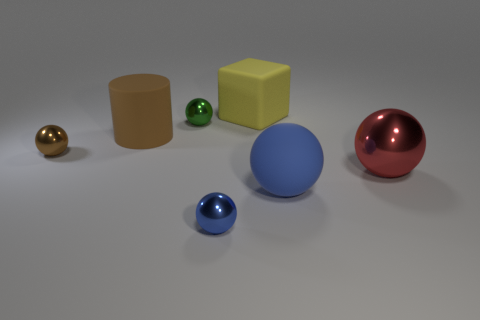Can you describe the size and color of the objects on the left side? On the left side, there are three objects: a small, shiny gold sphere; a medium-sized matte brown cylinder; and a small, shiny green sphere. The size of these spheres increases from the gold to the green one, while the cylinder is taller and wider than both spheres. 